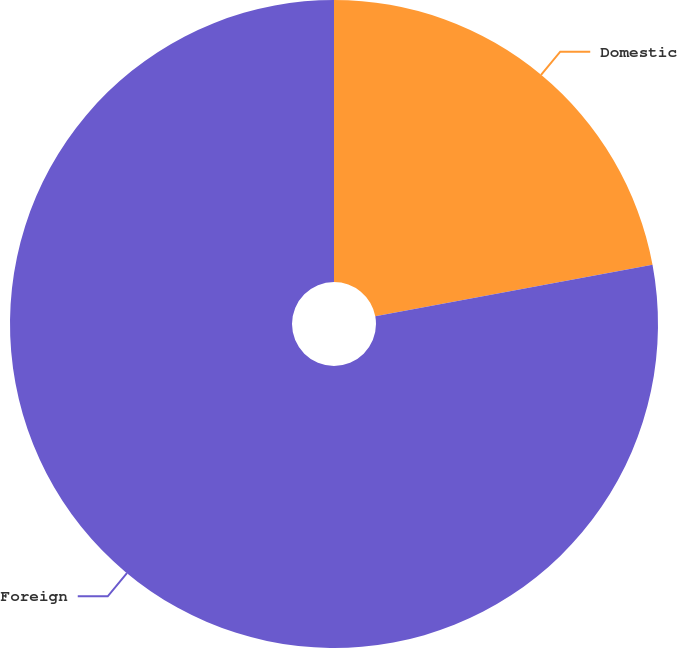Convert chart. <chart><loc_0><loc_0><loc_500><loc_500><pie_chart><fcel>Domestic<fcel>Foreign<nl><fcel>22.07%<fcel>77.93%<nl></chart> 